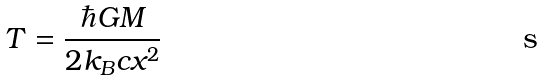<formula> <loc_0><loc_0><loc_500><loc_500>T = \frac { \hbar { G } M } { 2 k _ { B } c x ^ { 2 } }</formula> 